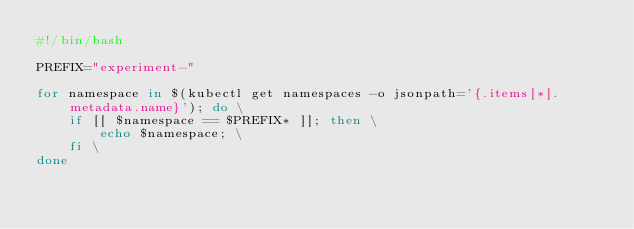<code> <loc_0><loc_0><loc_500><loc_500><_Bash_>#!/bin/bash

PREFIX="experiment-"

for namespace in $(kubectl get namespaces -o jsonpath='{.items[*].metadata.name}'); do \
    if [[ $namespace == $PREFIX* ]]; then \
        echo $namespace; \
    fi \
done</code> 